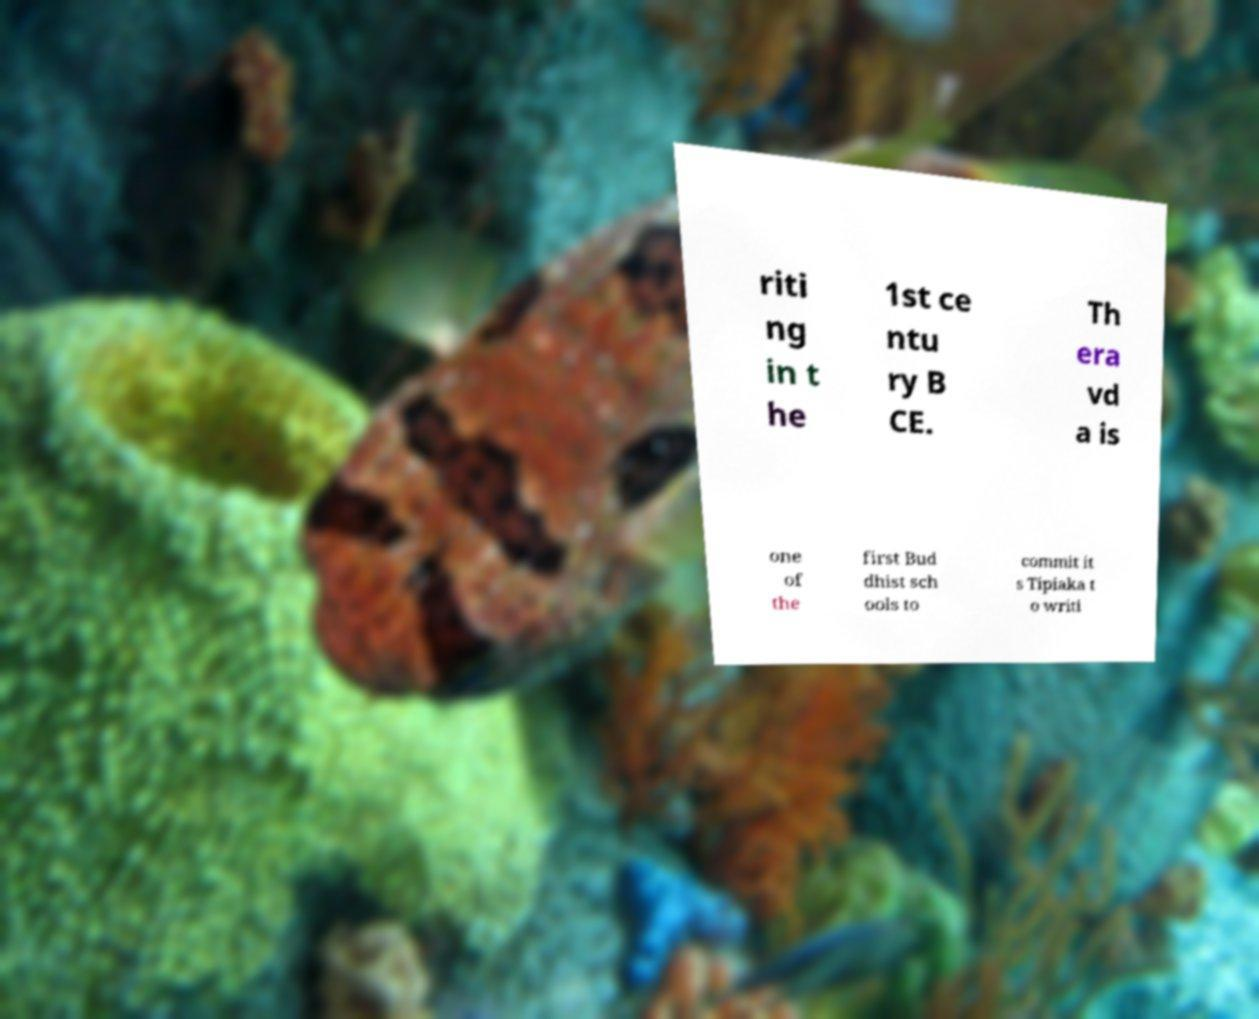For documentation purposes, I need the text within this image transcribed. Could you provide that? riti ng in t he 1st ce ntu ry B CE. Th era vd a is one of the first Bud dhist sch ools to commit it s Tipiaka t o writi 